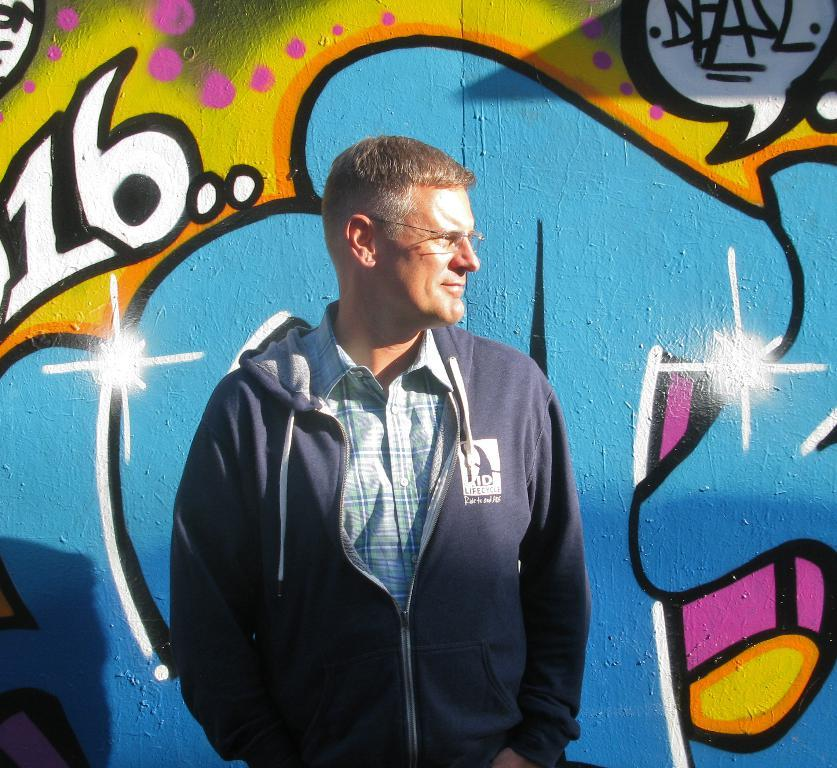What is the main subject of the image? There is a person in the image. Can you describe the person's appearance? The person is wearing spectacles. What is the person doing in the image? The person is standing. What can be seen on the wall behind the person? There are paintings on the wall behind the person. What month is the governor celebrating in the image? There is no governor present in the image, nor is there any indication of a celebration or a specific month. 